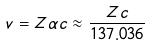Convert formula to latex. <formula><loc_0><loc_0><loc_500><loc_500>v = Z \alpha c \approx \frac { Z c } { 1 3 7 . 0 3 6 }</formula> 